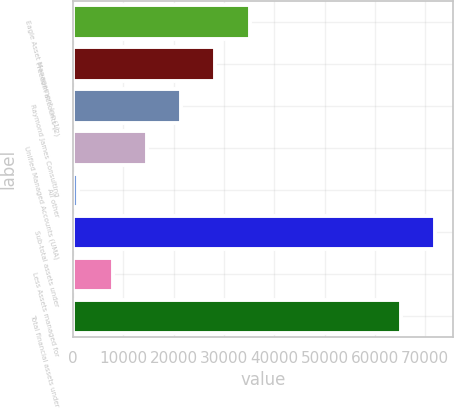<chart> <loc_0><loc_0><loc_500><loc_500><bar_chart><fcel>Eagle Asset Management Inc (1)<fcel>Freedom accounts (2)<fcel>Raymond James Consulting<fcel>Unified Managed Accounts (UMA)<fcel>All other<fcel>Sub-total assets under<fcel>Less Assets managed for<fcel>Total financial assets under<nl><fcel>35104.5<fcel>28306.8<fcel>21509.1<fcel>14711.4<fcel>1116<fcel>71974.7<fcel>7913.7<fcel>65177<nl></chart> 